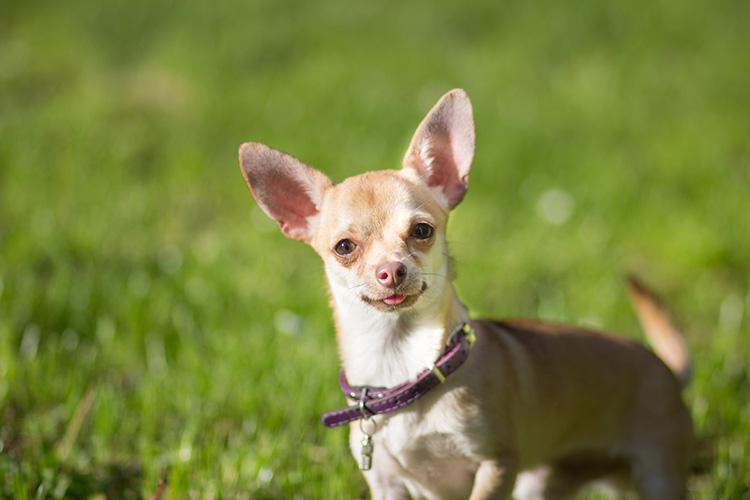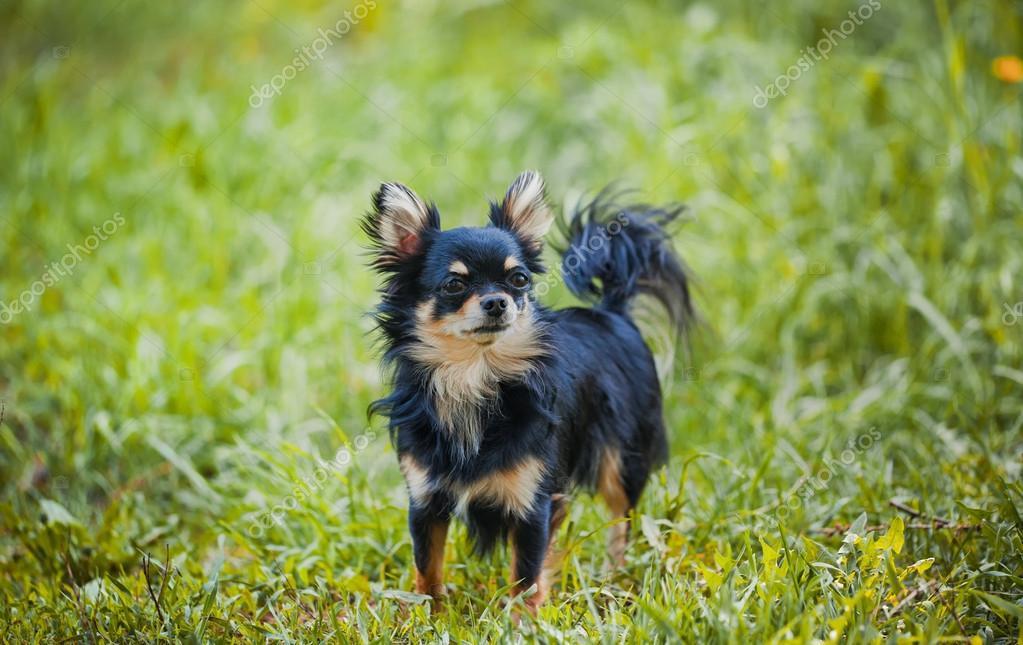The first image is the image on the left, the second image is the image on the right. For the images shown, is this caption "Both dogs are looking toward the camera." true? Answer yes or no. No. 